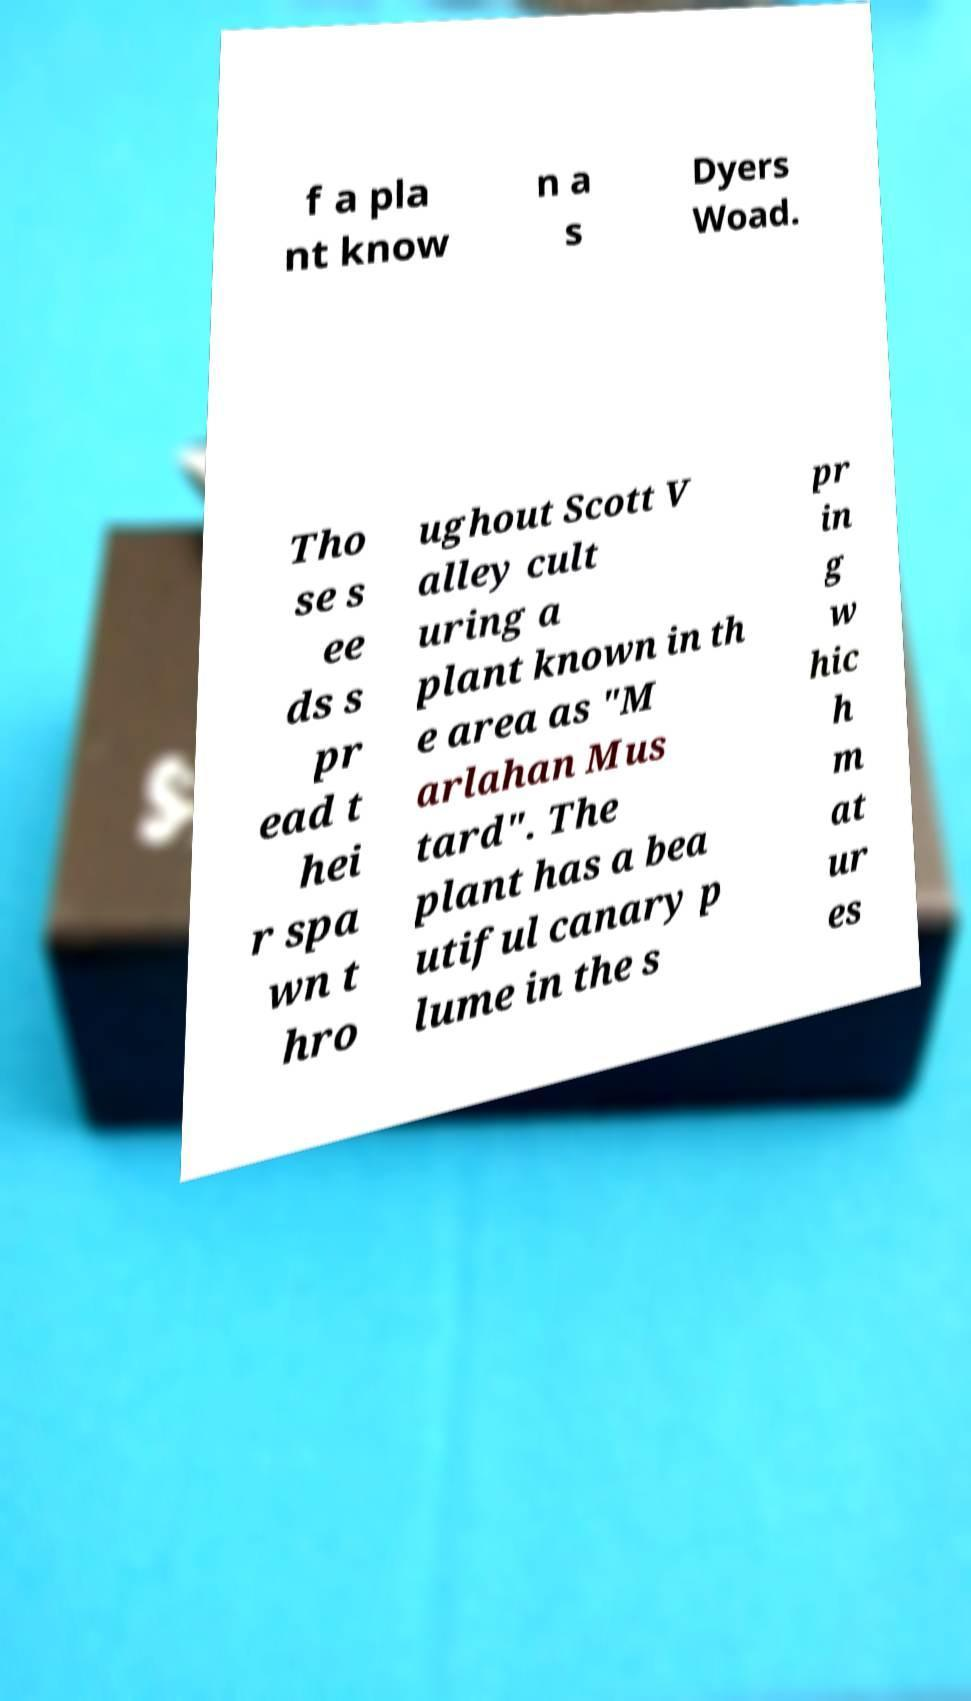What messages or text are displayed in this image? I need them in a readable, typed format. f a pla nt know n a s Dyers Woad. Tho se s ee ds s pr ead t hei r spa wn t hro ughout Scott V alley cult uring a plant known in th e area as "M arlahan Mus tard". The plant has a bea utiful canary p lume in the s pr in g w hic h m at ur es 